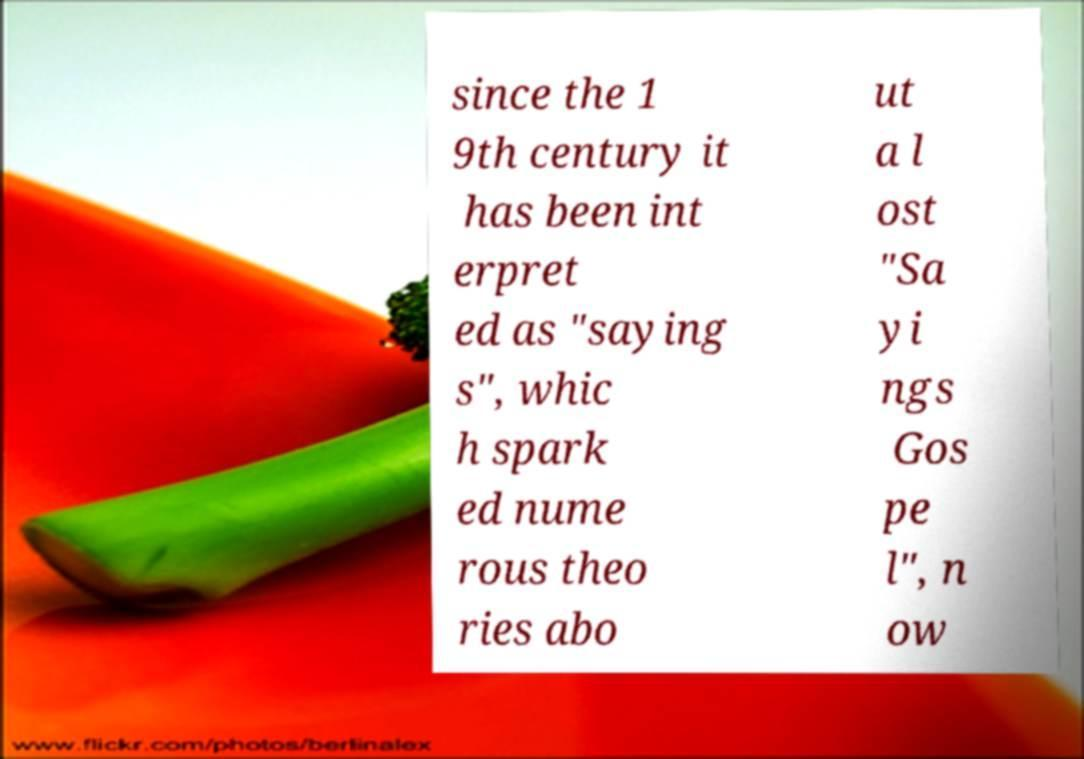Could you extract and type out the text from this image? since the 1 9th century it has been int erpret ed as "saying s", whic h spark ed nume rous theo ries abo ut a l ost "Sa yi ngs Gos pe l", n ow 